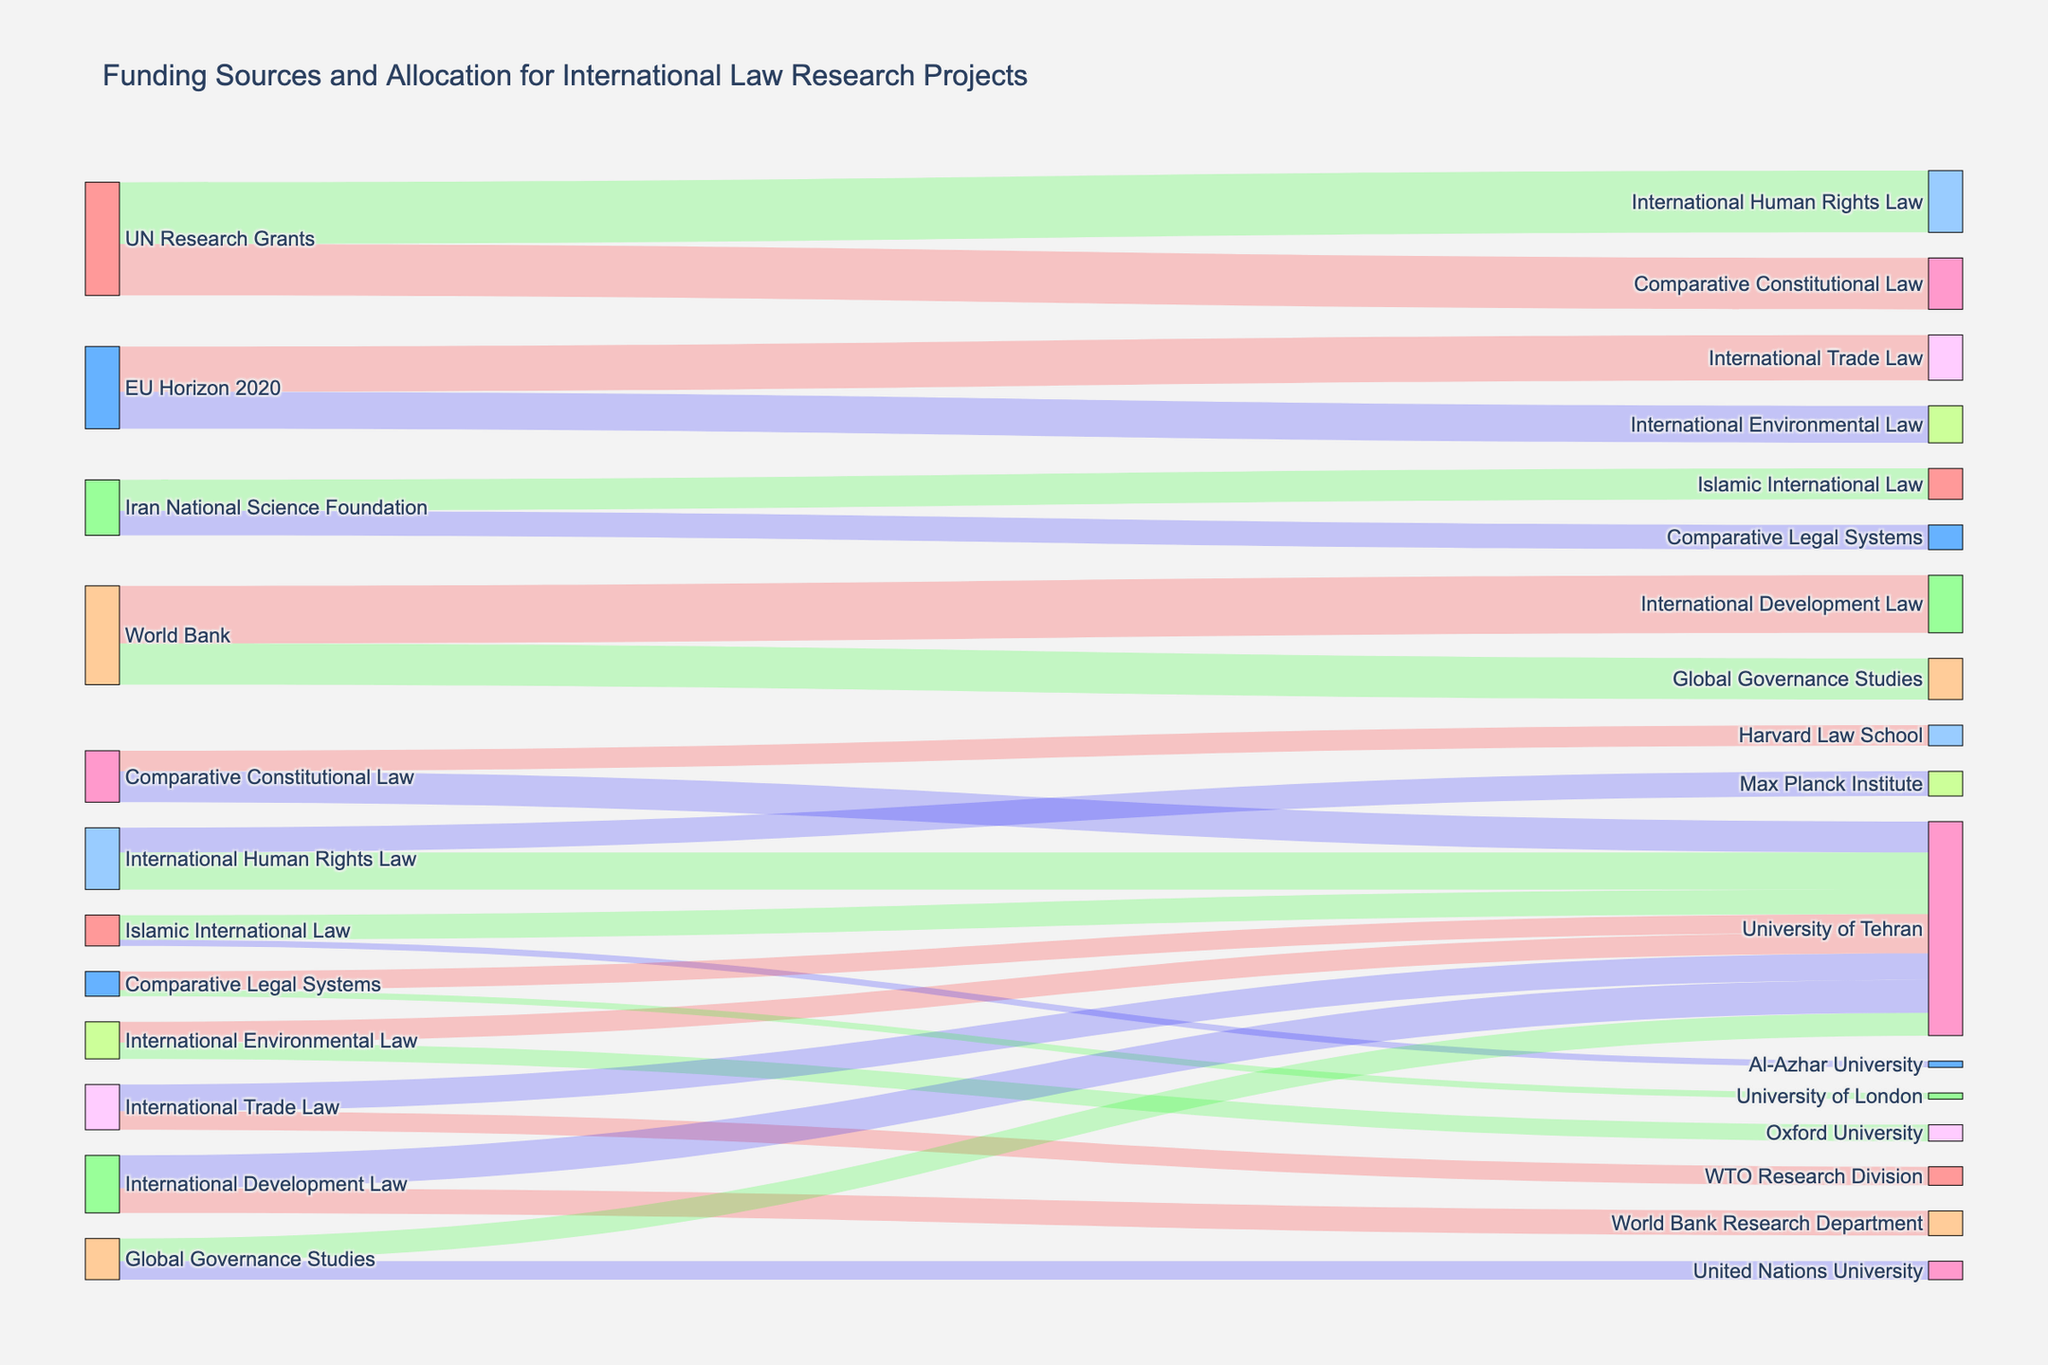What are the main funding sources for international law research projects in the data? From the Sankey Diagram, the main funding sources are clearly labeled as the initial nodes. The sources include "UN Research Grants," "EU Horizon 2020," "Iran National Science Foundation," and "World Bank."
Answer: "UN Research Grants," "EU Horizon 2020," "Iran National Science Foundation," "World Bank" What is the total funding amount allocated by the UN Research Grants? To find the total funding from UN Research Grants, sum the values for its connections: 2,500,000 for Comparative Constitutional Law and 3,000,000 for International Human Rights Law. The sum is 2,500,000 + 3,000,000 = 5,500,000.
Answer: 5,500,000 Which research project at the University of Tehran received the highest funding? By tracing the connections to the University of Tehran and comparing the values, we find that the International Human Rights Law project received 1,800,000, which is the highest among the projects listed.
Answer: International Human Rights Law How does the funding for Comparative Constitutional Law from Harvard Law School compare to that from the University of Tehran? The Sankey Diagram shows Harvard Law School receiving 1,000,000 and the University of Tehran receiving 1,500,000 for Comparative Constitutional Law. Comparatively, the University of Tehran received 500,000 more.
Answer: University of Tehran received 500,000 more Which institution received funding for both "International Development Law" and "Global Governance Studies," and what is the total amount they received? The University of Tehran received funding for both International Development Law (1,600,000) and Global Governance Studies (1,100,000). Summing these values, the total is 1,600,000 + 1,100,000 = 2,700,000.
Answer: University of Tehran, 2,700,000 What's the ratio of the funding from the World Bank to the University of Tehran for International Development Law compared to the funding to the World Bank Research Department for the same category? The University of Tehran received 1,600,000, and the World Bank Research Department received 1,200,000. The ratio is 1,600,000 / 1,200,000 = 4/3 or approximately 1.33.
Answer: 1.33 What percentage of the total funding for International Trade Law went to the University of Tehran? The total funding for International Trade Law is 2,200,000. The University of Tehran received 1,300,000. The percentage is (1,300,000 / 2,200,000) * 100 = 59.09%.
Answer: 59.09% Which research project receives funding from the most diverse set of sources? By inspecting the Sankey Diagram, Comparative Constitutional Law receives funding from two sources: UN Research Grants and contributions to two different institutions (University of Tehran and Harvard Law School). It has the most diverse funding sources.
Answer: Comparative Constitutional Law Is there any research project in the figure only funded by one funding entity? If yes, which one? Islamic International Law is only funded by the Iran National Science Foundation, according to the single connection seen in the diagram.
Answer: Islamic International Law What is the combined total funding of all research projects funded by the EU Horizon 2020? The EU Horizon 2020 funds International Environmental Law with 1,800,000 and International Trade Law with 2,200,000. Their combined total is 1,800,000 + 2,200,000 = 4,000,000.
Answer: 4,000,000 